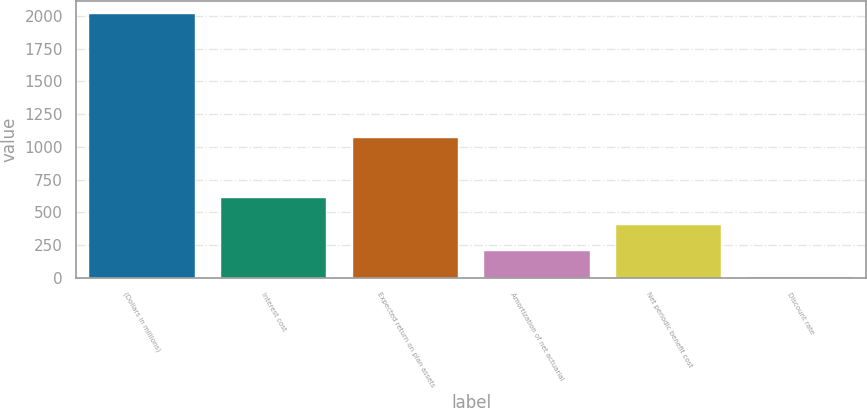<chart> <loc_0><loc_0><loc_500><loc_500><bar_chart><fcel>(Dollars in millions)<fcel>Interest cost<fcel>Expected return on plan assets<fcel>Amortization of net actuarial<fcel>Net periodic benefit cost<fcel>Discount rate<nl><fcel>2017<fcel>608<fcel>1068<fcel>205.44<fcel>406.72<fcel>4.16<nl></chart> 